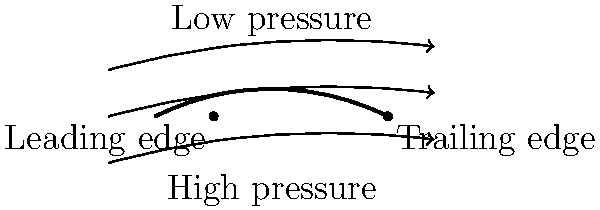In the airfoil diagram, which factor primarily contributes to the generation of lift, and how does it relate to the pressure distribution around the airfoil? To understand lift generation and pressure distribution around an airfoil, let's follow these steps:

1. Airfoil shape: The airfoil has a curved upper surface and a flatter lower surface, creating an asymmetrical shape.

2. Air flow: As air flows over the airfoil, it must travel a longer distance over the curved upper surface compared to the lower surface.

3. Bernoulli's principle: According to Bernoulli's principle, an increase in the speed of a fluid occurs simultaneously with a decrease in pressure.

4. Pressure difference: The air moving over the upper surface travels faster to cover the longer distance in the same time as the air moving under the airfoil. This results in lower pressure above the airfoil and higher pressure below.

5. Lift generation: The pressure difference between the upper and lower surfaces of the airfoil creates an upward force called lift.

6. Angle of attack: The angle at which the airfoil meets the oncoming air (angle of attack) can further enhance this pressure difference and increase lift.

7. Streamlines: The streamlines in the diagram illustrate the air flow pattern around the airfoil, showing how they curve around the shape and are deflected downward behind the airfoil.

The primary factor contributing to lift generation is the pressure difference caused by the airfoil's shape and its interaction with the airflow.
Answer: Pressure difference due to airfoil shape 